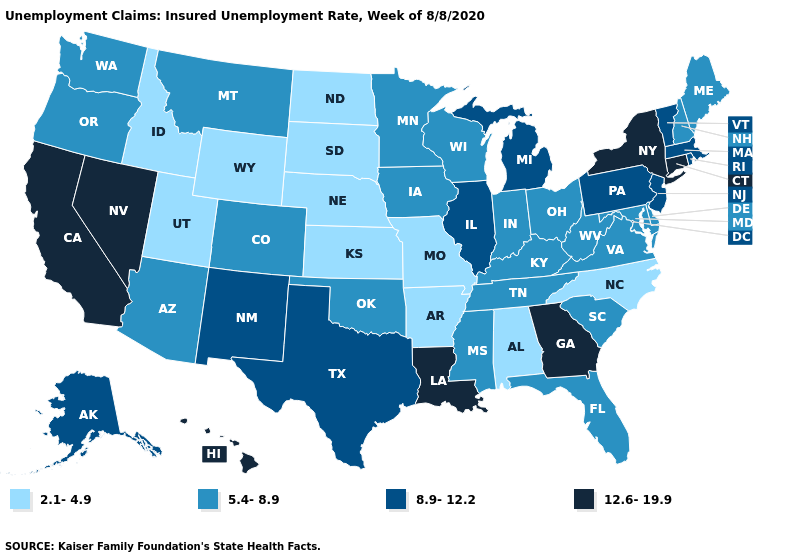Which states have the highest value in the USA?
Answer briefly. California, Connecticut, Georgia, Hawaii, Louisiana, Nevada, New York. What is the highest value in states that border Ohio?
Concise answer only. 8.9-12.2. What is the value of Arkansas?
Short answer required. 2.1-4.9. What is the value of Vermont?
Keep it brief. 8.9-12.2. Name the states that have a value in the range 2.1-4.9?
Short answer required. Alabama, Arkansas, Idaho, Kansas, Missouri, Nebraska, North Carolina, North Dakota, South Dakota, Utah, Wyoming. What is the highest value in the USA?
Give a very brief answer. 12.6-19.9. Name the states that have a value in the range 2.1-4.9?
Concise answer only. Alabama, Arkansas, Idaho, Kansas, Missouri, Nebraska, North Carolina, North Dakota, South Dakota, Utah, Wyoming. What is the lowest value in the MidWest?
Write a very short answer. 2.1-4.9. Among the states that border Ohio , does Michigan have the highest value?
Short answer required. Yes. Is the legend a continuous bar?
Answer briefly. No. What is the lowest value in the USA?
Keep it brief. 2.1-4.9. What is the value of Alaska?
Concise answer only. 8.9-12.2. Does Massachusetts have the lowest value in the Northeast?
Give a very brief answer. No. Is the legend a continuous bar?
Keep it brief. No. Does the map have missing data?
Keep it brief. No. 